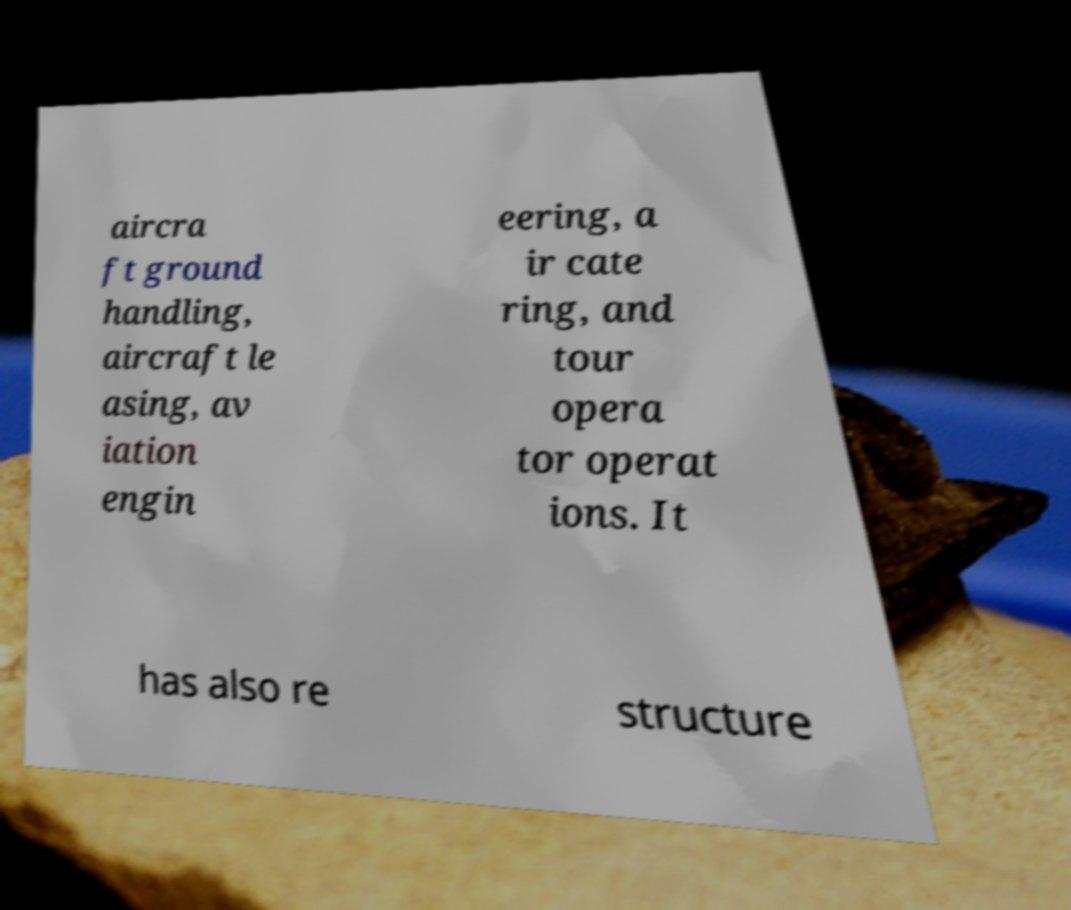Please identify and transcribe the text found in this image. aircra ft ground handling, aircraft le asing, av iation engin eering, a ir cate ring, and tour opera tor operat ions. It has also re structure 